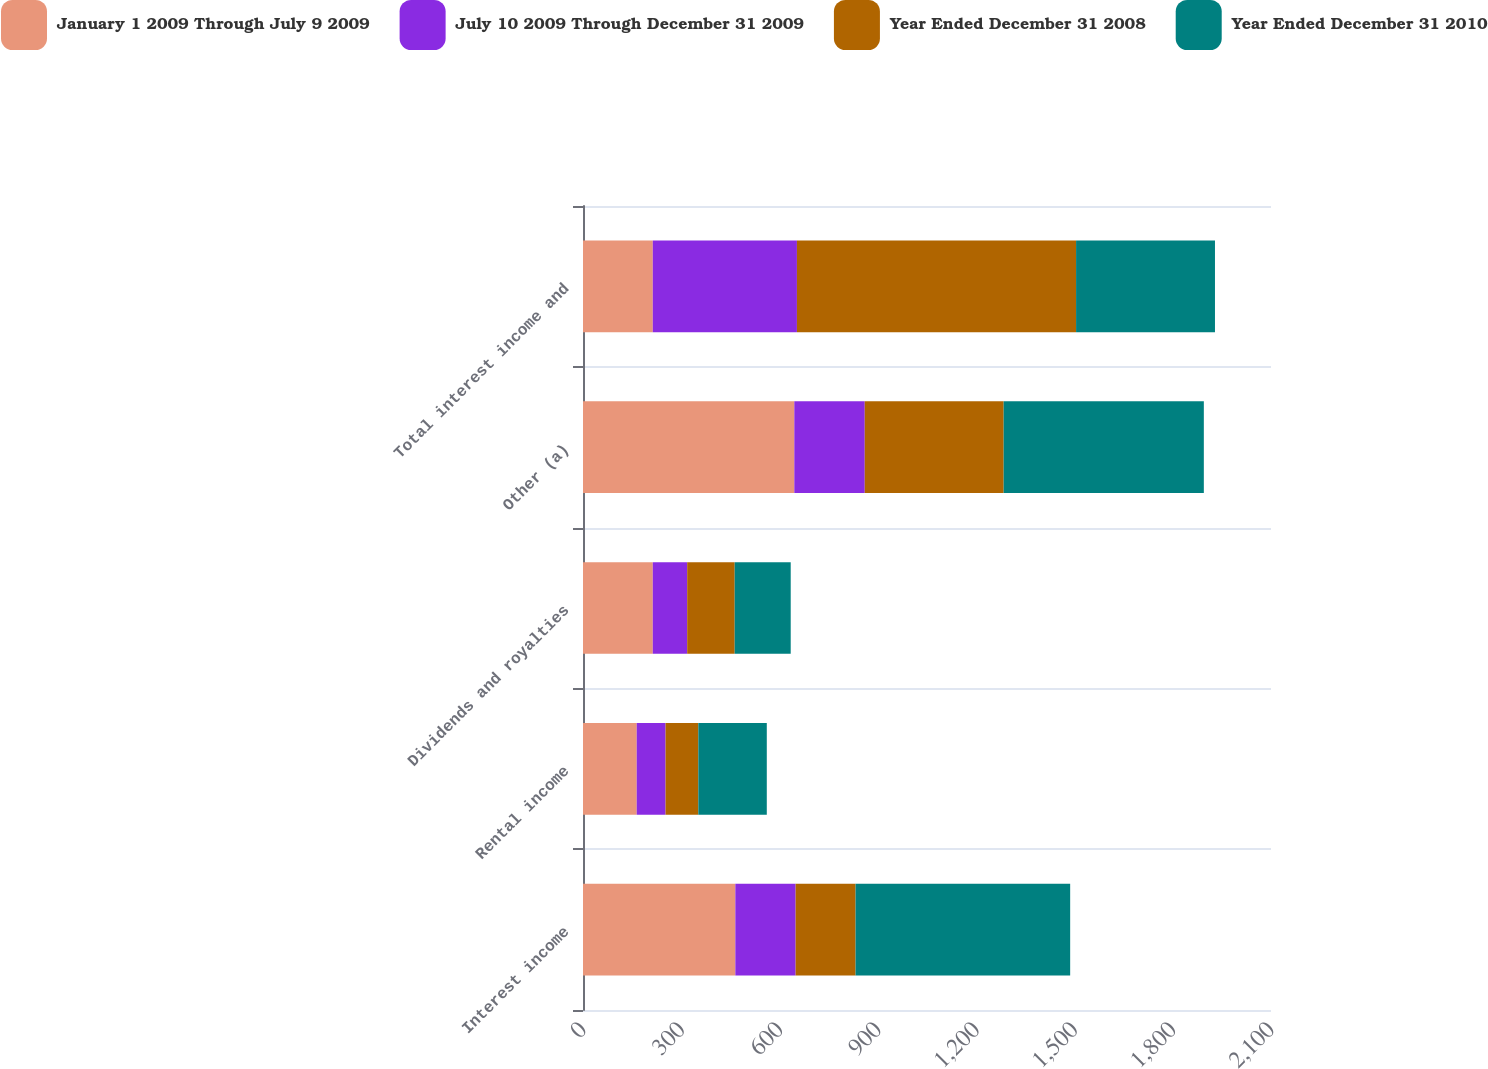<chart> <loc_0><loc_0><loc_500><loc_500><stacked_bar_chart><ecel><fcel>Interest income<fcel>Rental income<fcel>Dividends and royalties<fcel>Other (a)<fcel>Total interest income and<nl><fcel>January 1 2009 Through July 9 2009<fcel>465<fcel>164<fcel>213<fcel>645<fcel>213<nl><fcel>July 10 2009 Through December 31 2009<fcel>184<fcel>88<fcel>105<fcel>215<fcel>440<nl><fcel>Year Ended December 31 2008<fcel>183<fcel>100<fcel>145<fcel>424<fcel>852<nl><fcel>Year Ended December 31 2010<fcel>655<fcel>209<fcel>171<fcel>611<fcel>424<nl></chart> 